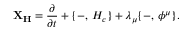<formula> <loc_0><loc_0><loc_500><loc_500>{ X _ { H } } = { \frac { \partial } { \partial t } } + \{ - , \, H _ { c } \} + \lambda _ { \mu } \{ - , \, \phi ^ { \mu } \} .</formula> 